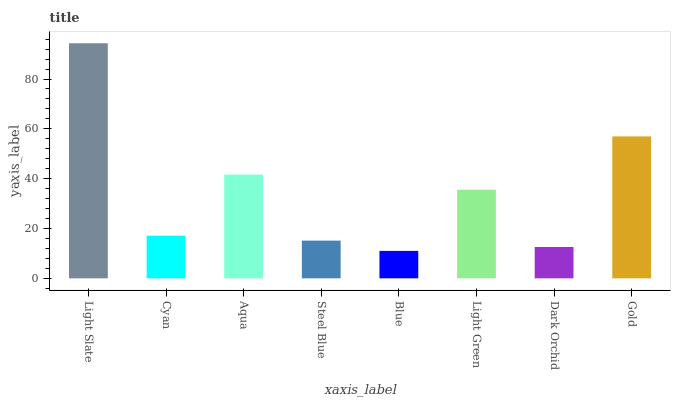Is Cyan the minimum?
Answer yes or no. No. Is Cyan the maximum?
Answer yes or no. No. Is Light Slate greater than Cyan?
Answer yes or no. Yes. Is Cyan less than Light Slate?
Answer yes or no. Yes. Is Cyan greater than Light Slate?
Answer yes or no. No. Is Light Slate less than Cyan?
Answer yes or no. No. Is Light Green the high median?
Answer yes or no. Yes. Is Cyan the low median?
Answer yes or no. Yes. Is Steel Blue the high median?
Answer yes or no. No. Is Light Green the low median?
Answer yes or no. No. 